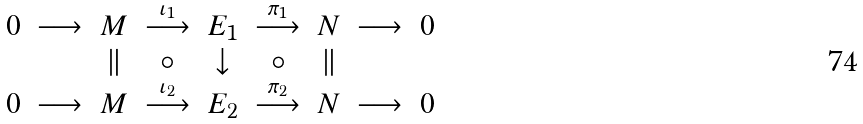<formula> <loc_0><loc_0><loc_500><loc_500>\begin{array} { c c c c c c c c c } 0 & \longrightarrow & M & \stackrel { \iota _ { 1 } } { \longrightarrow } & E _ { 1 } & \stackrel { \pi _ { 1 } } { \longrightarrow } & N & \longrightarrow & 0 \\ & & \| & \circ & \downarrow & \circ & \| & \\ 0 & \longrightarrow & M & \stackrel { \iota _ { 2 } } { \longrightarrow } & E _ { 2 } & \stackrel { \pi _ { 2 } } { \longrightarrow } & N & \longrightarrow & 0 \end{array}</formula> 